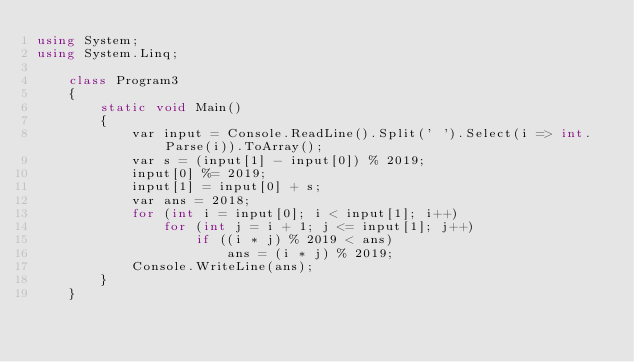<code> <loc_0><loc_0><loc_500><loc_500><_C#_>using System;
using System.Linq;

    class Program3
    {
        static void Main()
        {
            var input = Console.ReadLine().Split(' ').Select(i => int.Parse(i)).ToArray();
            var s = (input[1] - input[0]) % 2019;
            input[0] %= 2019;
            input[1] = input[0] + s;
            var ans = 2018;
            for (int i = input[0]; i < input[1]; i++)
                for (int j = i + 1; j <= input[1]; j++)
                    if ((i * j) % 2019 < ans)
                        ans = (i * j) % 2019;
            Console.WriteLine(ans);
        }
    }</code> 